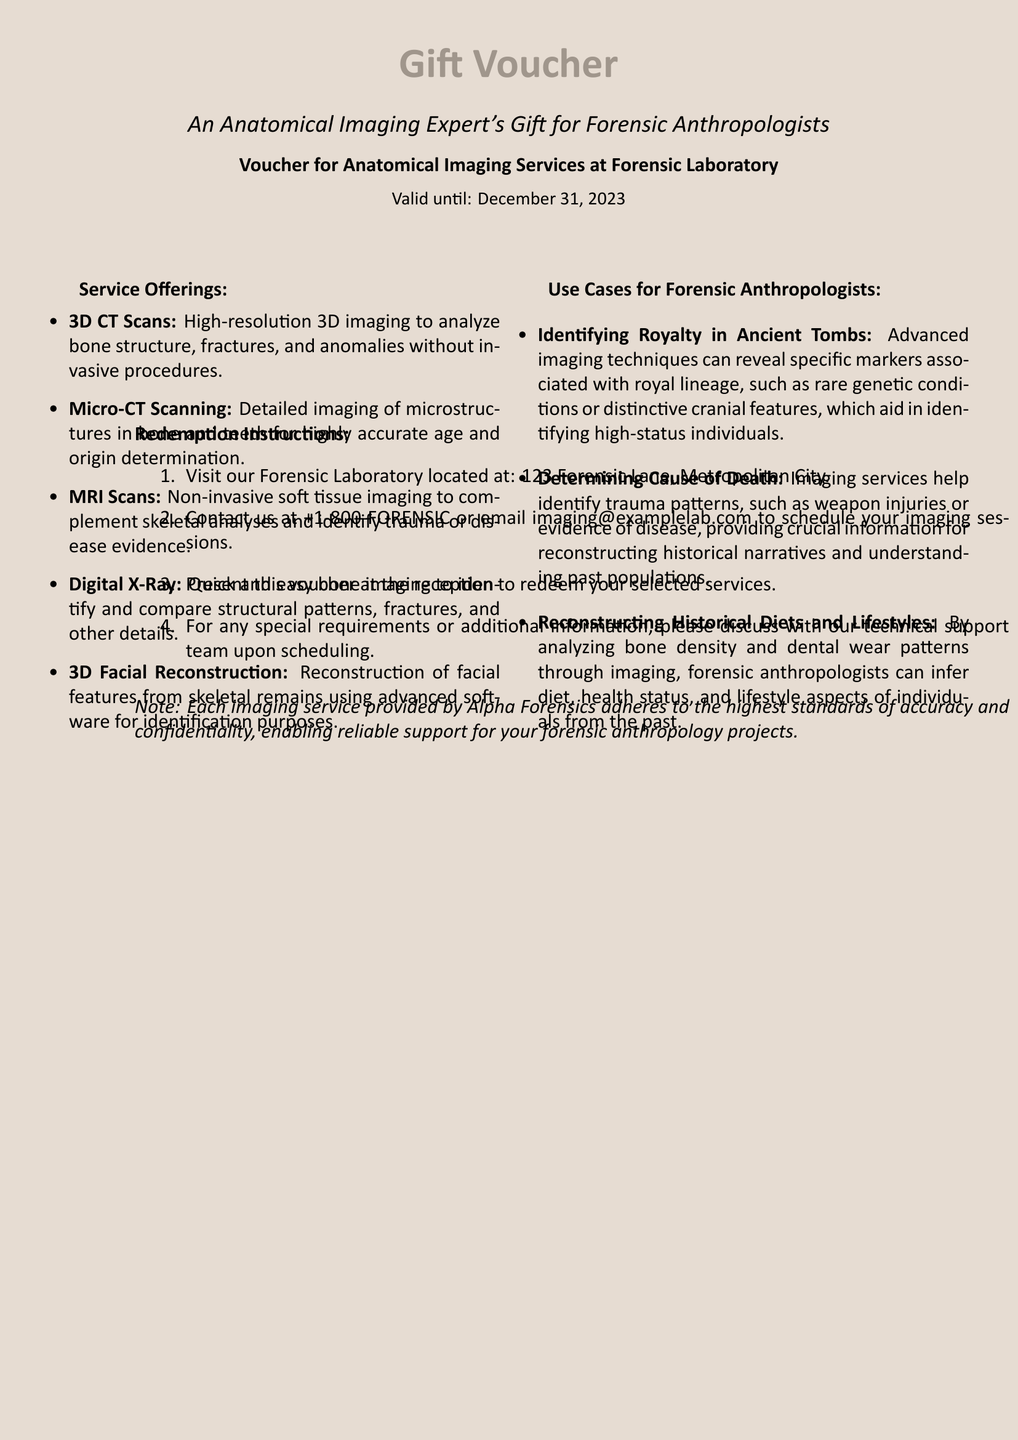What is the validity period of the voucher? The validity period of the voucher is stated in the document and is until December 31, 2023.
Answer: December 31, 2023 What is one type of imaging service offered? The document lists several imaging services, and one of them is 3D CT Scans.
Answer: 3D CT Scans Which imaging technique is used for soft tissue analysis? The document specifies MRI Scans for non-invasive soft tissue imaging.
Answer: MRI Scans What is one use case for forensic anthropologists mentioned? The document discusses various applications, including identifying royalty in ancient tombs.
Answer: Identifying Royalty in Ancient Tombs How can the voucher be redeemed? The redemption process is outlined in the document under redemption instructions starting with contacting the Forensic Laboratory.
Answer: Present this voucher at the reception What must you do to schedule an imaging session? The document indicates that you should contact the Forensic Laboratory to schedule imaging sessions.
Answer: Contact us at +1-800-FORENSIC What is the address of the Forensic Laboratory? The document provides the address for the Forensic Laboratory as 123 Forensic Lane, Metropolitan City.
Answer: 123 Forensic Lane, Metropolitan City What type of imaging helps identify historical diets? The document explains that bone density and dental wear patterns analyzed through imaging assist in this identification.
Answer: Analyzing bone density and dental wear patterns 